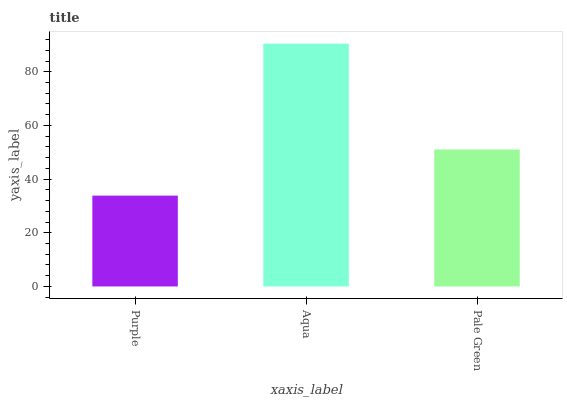Is Pale Green the minimum?
Answer yes or no. No. Is Pale Green the maximum?
Answer yes or no. No. Is Aqua greater than Pale Green?
Answer yes or no. Yes. Is Pale Green less than Aqua?
Answer yes or no. Yes. Is Pale Green greater than Aqua?
Answer yes or no. No. Is Aqua less than Pale Green?
Answer yes or no. No. Is Pale Green the high median?
Answer yes or no. Yes. Is Pale Green the low median?
Answer yes or no. Yes. Is Aqua the high median?
Answer yes or no. No. Is Aqua the low median?
Answer yes or no. No. 